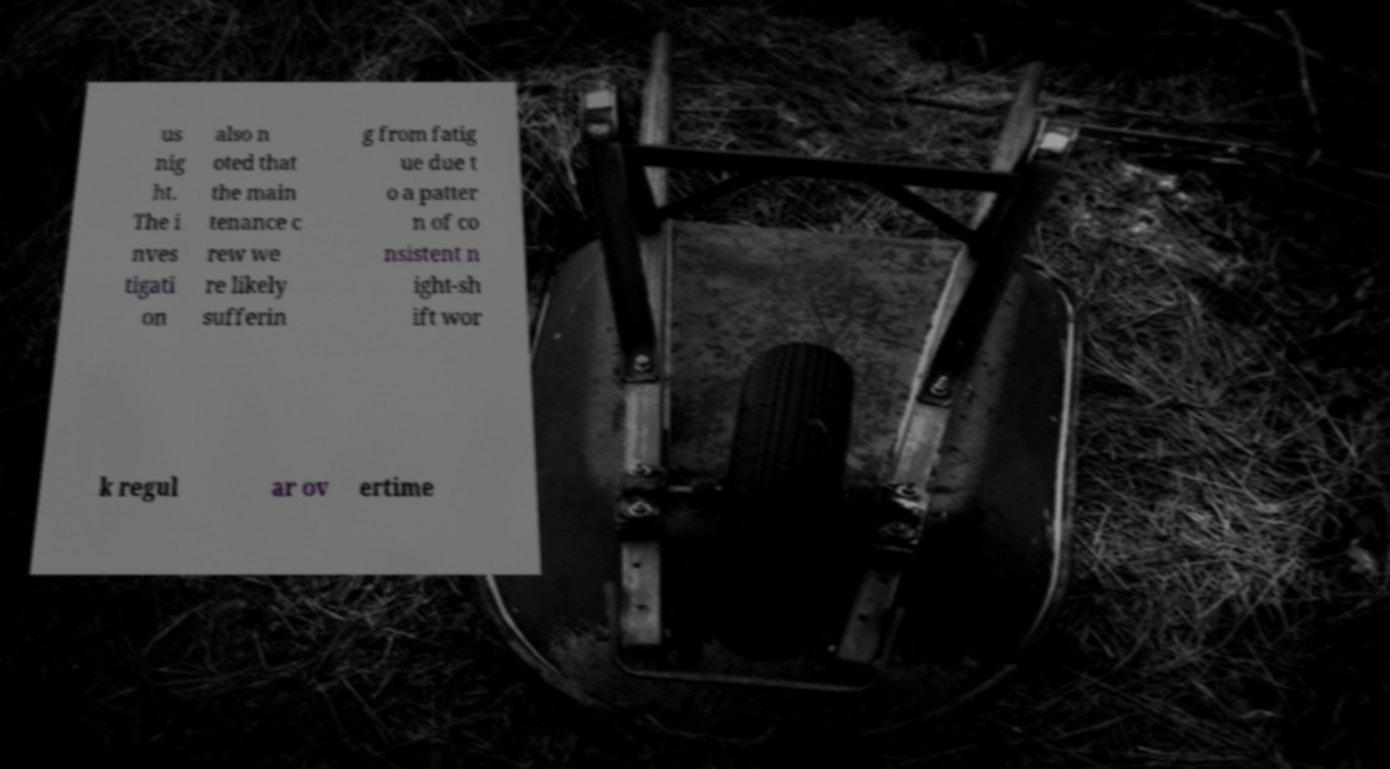Please identify and transcribe the text found in this image. us nig ht. The i nves tigati on also n oted that the main tenance c rew we re likely sufferin g from fatig ue due t o a patter n of co nsistent n ight-sh ift wor k regul ar ov ertime 